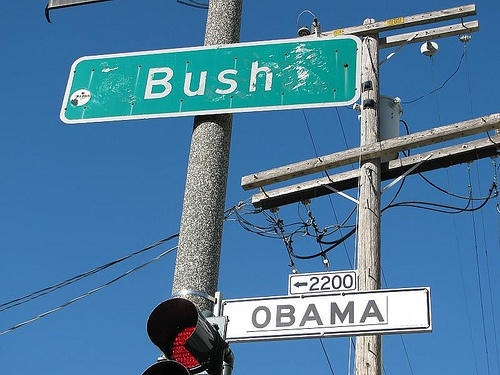Describe the objects in this image and their specific colors. I can see a traffic light in blue, black, gray, brown, and maroon tones in this image. 